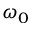Convert formula to latex. <formula><loc_0><loc_0><loc_500><loc_500>\omega _ { 0 }</formula> 